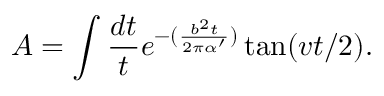Convert formula to latex. <formula><loc_0><loc_0><loc_500><loc_500>A = \int \frac { d t } { t } e ^ { - ( \frac { b ^ { 2 } t } { 2 \pi \alpha ^ { \prime } } ) } \tan ( v t / 2 ) .</formula> 